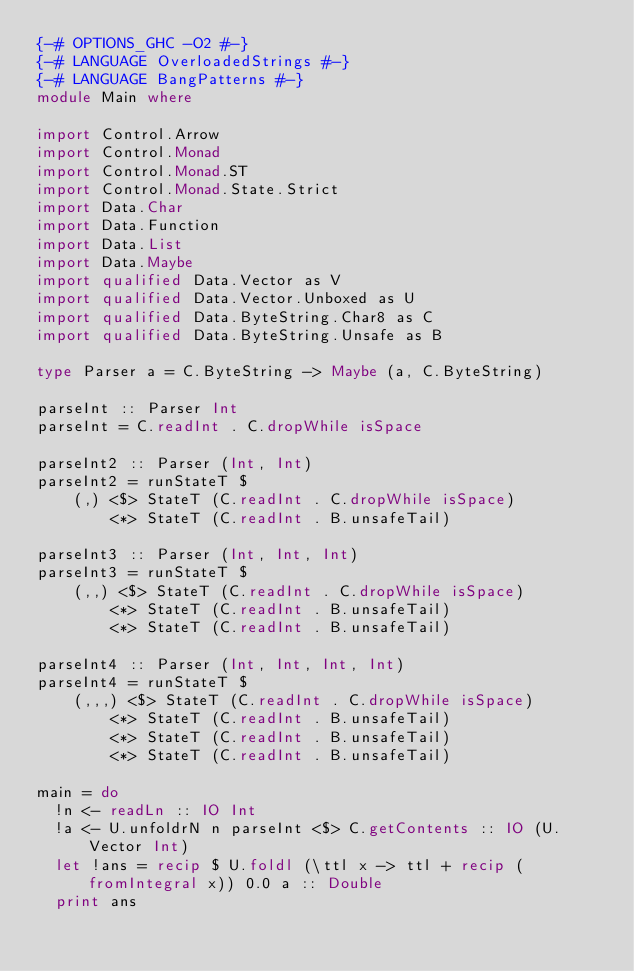<code> <loc_0><loc_0><loc_500><loc_500><_Haskell_>{-# OPTIONS_GHC -O2 #-}
{-# LANGUAGE OverloadedStrings #-}
{-# LANGUAGE BangPatterns #-}
module Main where

import Control.Arrow
import Control.Monad
import Control.Monad.ST
import Control.Monad.State.Strict
import Data.Char
import Data.Function
import Data.List
import Data.Maybe
import qualified Data.Vector as V
import qualified Data.Vector.Unboxed as U
import qualified Data.ByteString.Char8 as C
import qualified Data.ByteString.Unsafe as B

type Parser a = C.ByteString -> Maybe (a, C.ByteString)

parseInt :: Parser Int
parseInt = C.readInt . C.dropWhile isSpace

parseInt2 :: Parser (Int, Int)
parseInt2 = runStateT $
    (,) <$> StateT (C.readInt . C.dropWhile isSpace)
        <*> StateT (C.readInt . B.unsafeTail)
 
parseInt3 :: Parser (Int, Int, Int)
parseInt3 = runStateT $
    (,,) <$> StateT (C.readInt . C.dropWhile isSpace)
        <*> StateT (C.readInt . B.unsafeTail)
        <*> StateT (C.readInt . B.unsafeTail)
 
parseInt4 :: Parser (Int, Int, Int, Int)
parseInt4 = runStateT $
    (,,,) <$> StateT (C.readInt . C.dropWhile isSpace)
        <*> StateT (C.readInt . B.unsafeTail)
        <*> StateT (C.readInt . B.unsafeTail)
        <*> StateT (C.readInt . B.unsafeTail)

main = do
  !n <- readLn :: IO Int
  !a <- U.unfoldrN n parseInt <$> C.getContents :: IO (U.Vector Int)
  let !ans = recip $ U.foldl (\ttl x -> ttl + recip (fromIntegral x)) 0.0 a :: Double
  print ans
</code> 